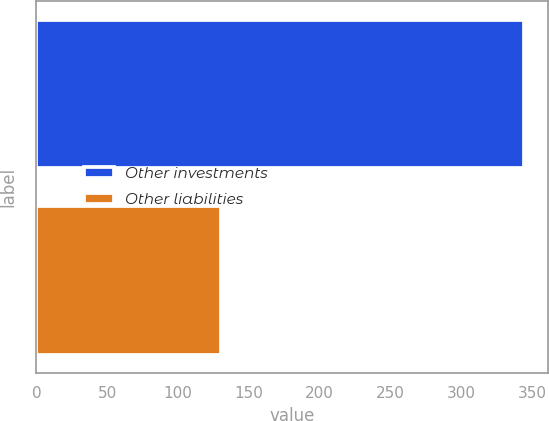Convert chart to OTSL. <chart><loc_0><loc_0><loc_500><loc_500><bar_chart><fcel>Other investments<fcel>Other liabilities<nl><fcel>344<fcel>130<nl></chart> 